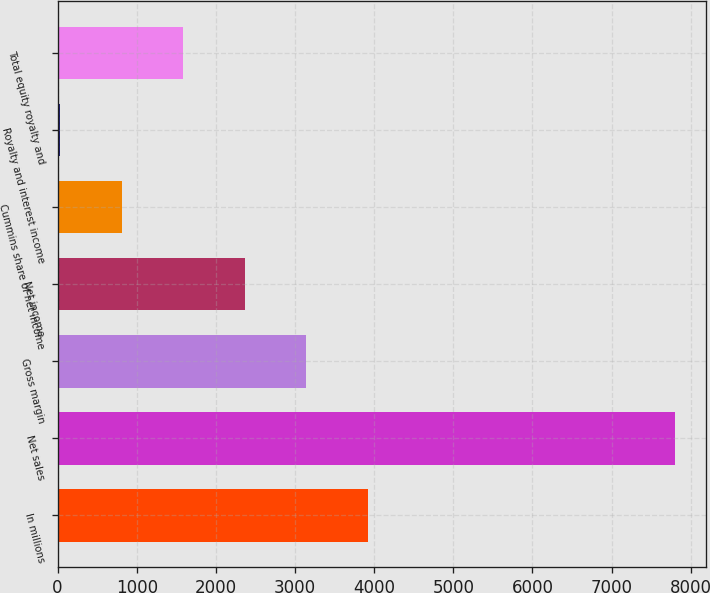<chart> <loc_0><loc_0><loc_500><loc_500><bar_chart><fcel>In millions<fcel>Net sales<fcel>Gross margin<fcel>Net income<fcel>Cummins share of net income<fcel>Royalty and interest income<fcel>Total equity royalty and<nl><fcel>3917.5<fcel>7799<fcel>3141.2<fcel>2364.9<fcel>812.3<fcel>36<fcel>1588.6<nl></chart> 